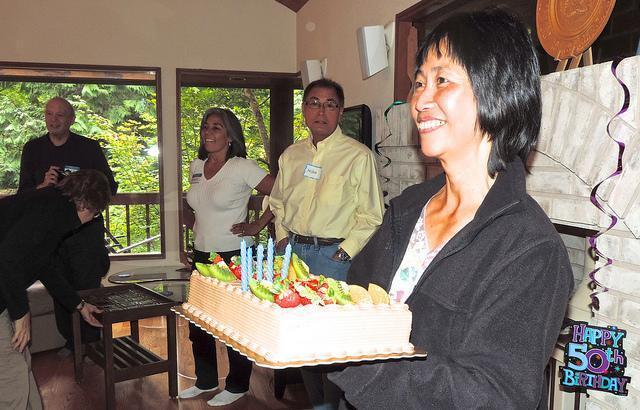How many candles are on that cake?
Give a very brief answer. 5. How many people are there here?
Give a very brief answer. 5. How many people are in the picture?
Give a very brief answer. 5. 